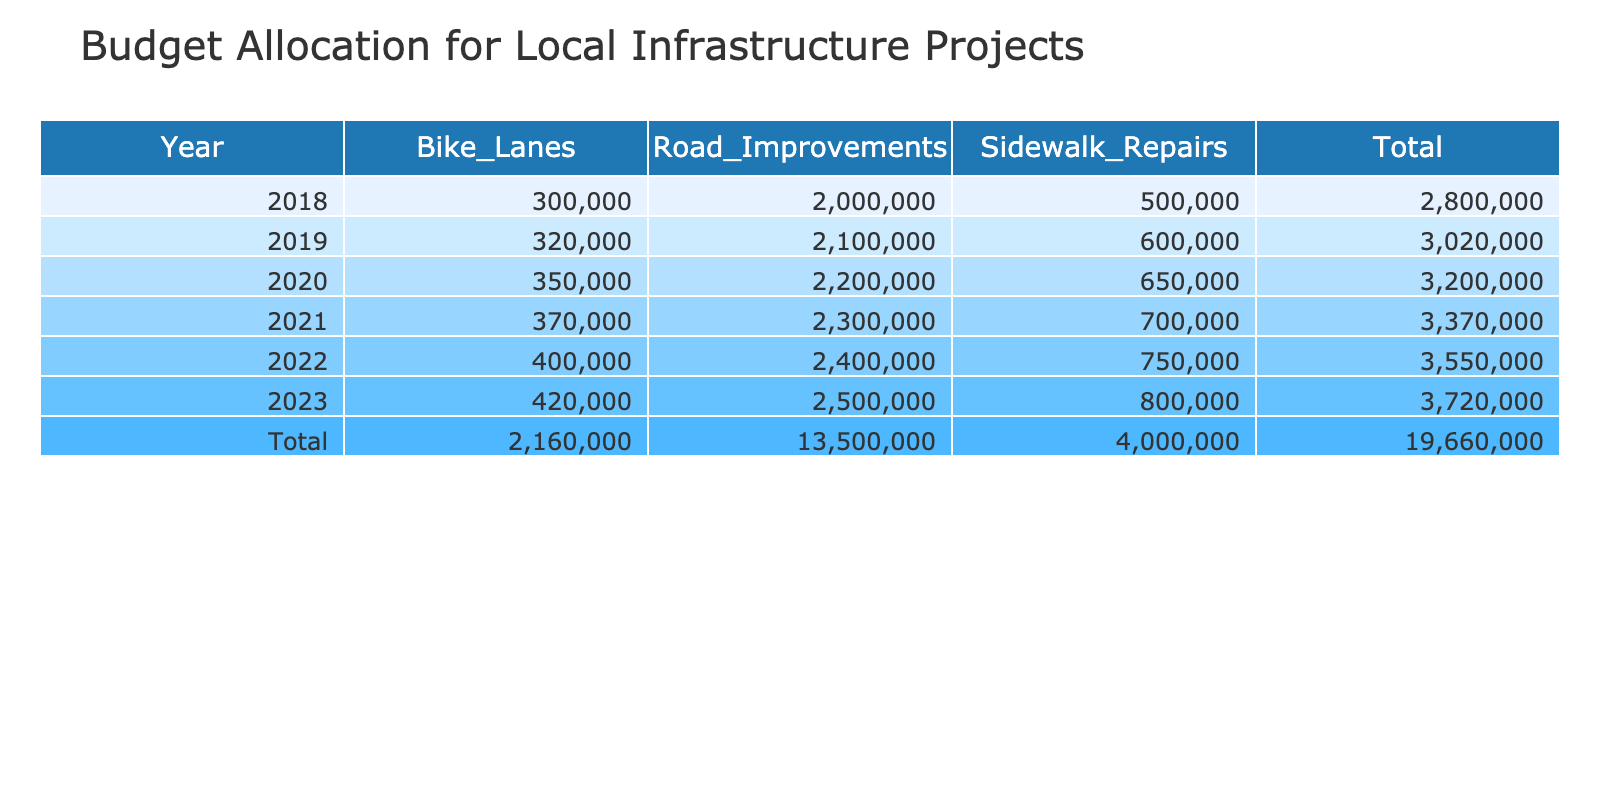What was the total budget allocation for bike lanes in 2020? In 2020, the budget allocation for bike lanes is directly provided in the table as 350000 USD.
Answer: 350000 Which year had the highest budget allocation for road improvements? The table shows the budget allocation for road improvements for each year. Summarizing the data, 2023 has the highest allocation at 2500000 USD.
Answer: 2023 What is the average budget allocation for sidewalk repairs over the years? The sidewalk repair allocations are 500000, 600000, 650000, 700000, 750000, and 800000. Summing these values gives 4050000. Dividing by the number of years (6) gives an average of 675000 USD.
Answer: 675000 Did the budget allocation for bike lanes increase every year? Looking at the bike lane allocations: 300000, 320000, 350000, 370000, 400000, and 420000, it can be observed that these amounts are increasing each year. So, yes, the budget allocation increased every year.
Answer: Yes What was the total budget allocation for infrastructure projects in 2021? From the table, the allocations for 2021 are: Road Improvements (2300000), Sidewalk Repairs (700000), and Bike Lanes (370000). Adding these amounts together gives a total of 2300000 + 700000 + 370000 = 3370000 USD.
Answer: 3370000 How much more was allocated to road improvements in 2022 compared to bike lanes in 2021? The allocation for road improvements in 2022 was 2400000 USD, while the allocation for bike lanes in 2021 was 370000 USD. The difference is calculated as 2400000 - 370000 = 2030000 USD.
Answer: 2030000 In which year did the combined budget for sidewalk repairs and bike lanes exceed 1 million dollars? The combined budget for sidewalk repairs and bike lanes can be calculated for each year. For every year from 2021 onwards, the total allocations were: 700000 + 370000, 750000 + 400000, and 800000 + 420000. All of these sums (1070000, 1150000, and 1220000 respectively) exceed 1 million. The year 2021 was the first occurrence.
Answer: 2021 Which infrastructure type received the least budget allocation in 2019? In 2019, the allocation for Road Improvements was 2100000, for Sidewalk Repairs was 600000, and for Bike Lanes was 320000. Comparing these, the least allocation is for Sidewalk Repairs at 600000 USD.
Answer: Sidewalk Repairs What is the total budget allocation for bike lanes from 2018 to 2023? Summing the allocations for bike lanes over the years gives: 300000 (2018) + 320000 (2019) + 350000 (2020) + 370000 (2021) + 400000 (2022) + 420000 (2023). This totals to 300000 + 320000 + 350000 + 370000 + 400000 + 420000 = 2160000 USD.
Answer: 2160000 